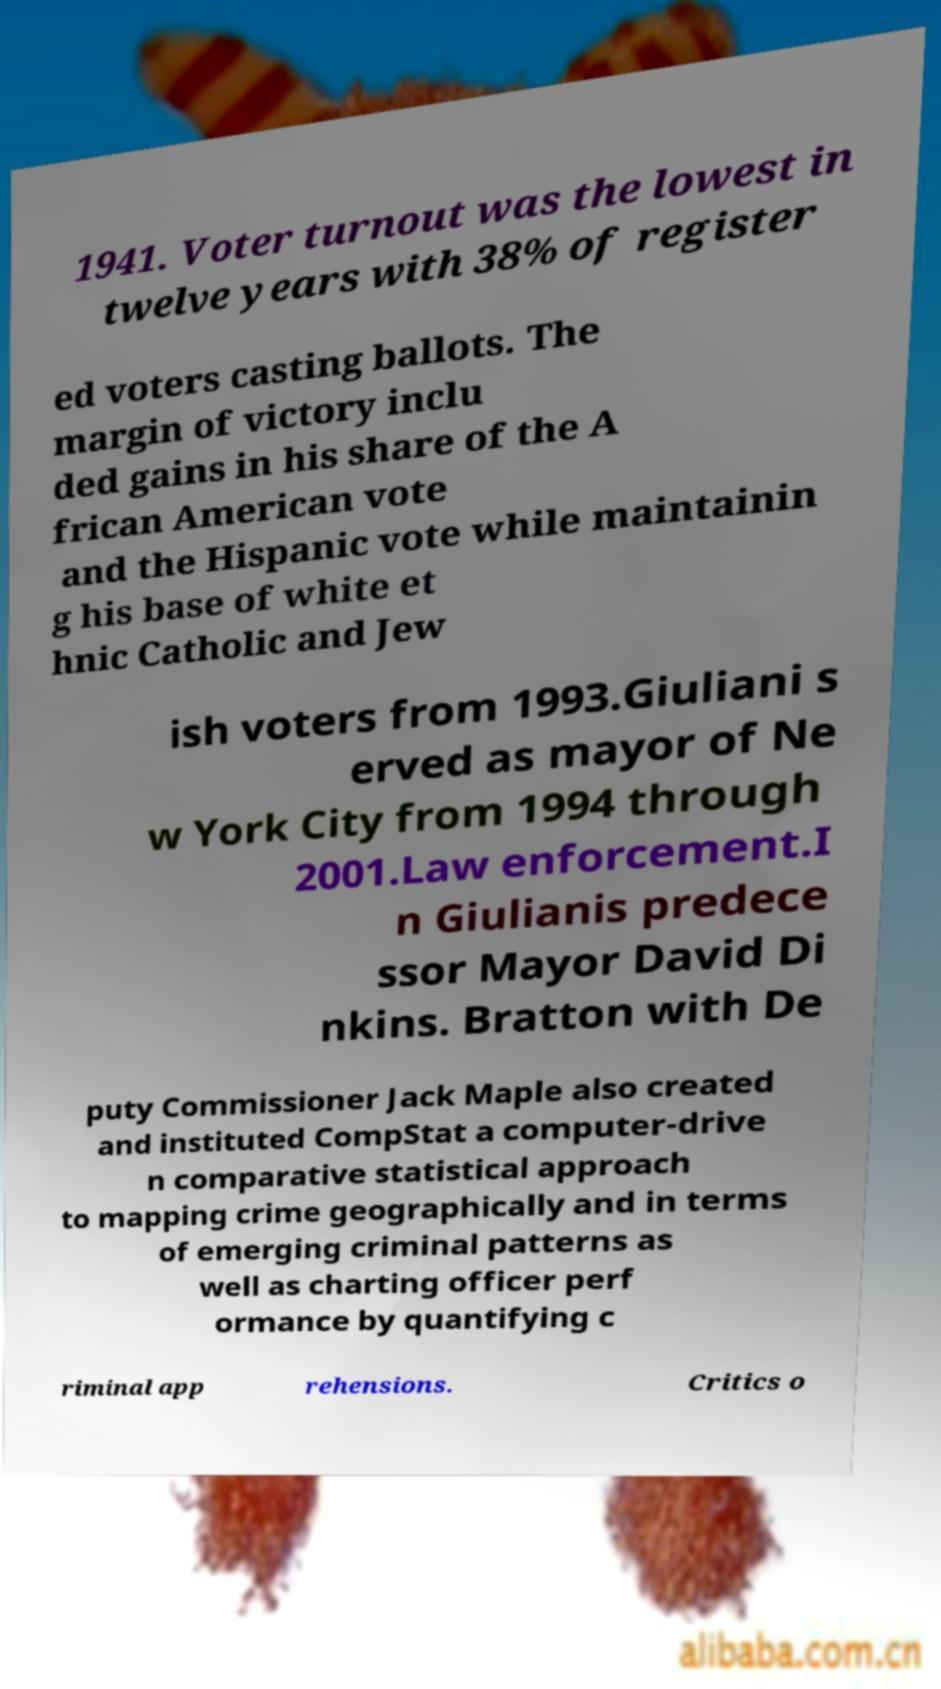What messages or text are displayed in this image? I need them in a readable, typed format. 1941. Voter turnout was the lowest in twelve years with 38% of register ed voters casting ballots. The margin of victory inclu ded gains in his share of the A frican American vote and the Hispanic vote while maintainin g his base of white et hnic Catholic and Jew ish voters from 1993.Giuliani s erved as mayor of Ne w York City from 1994 through 2001.Law enforcement.I n Giulianis predece ssor Mayor David Di nkins. Bratton with De puty Commissioner Jack Maple also created and instituted CompStat a computer-drive n comparative statistical approach to mapping crime geographically and in terms of emerging criminal patterns as well as charting officer perf ormance by quantifying c riminal app rehensions. Critics o 